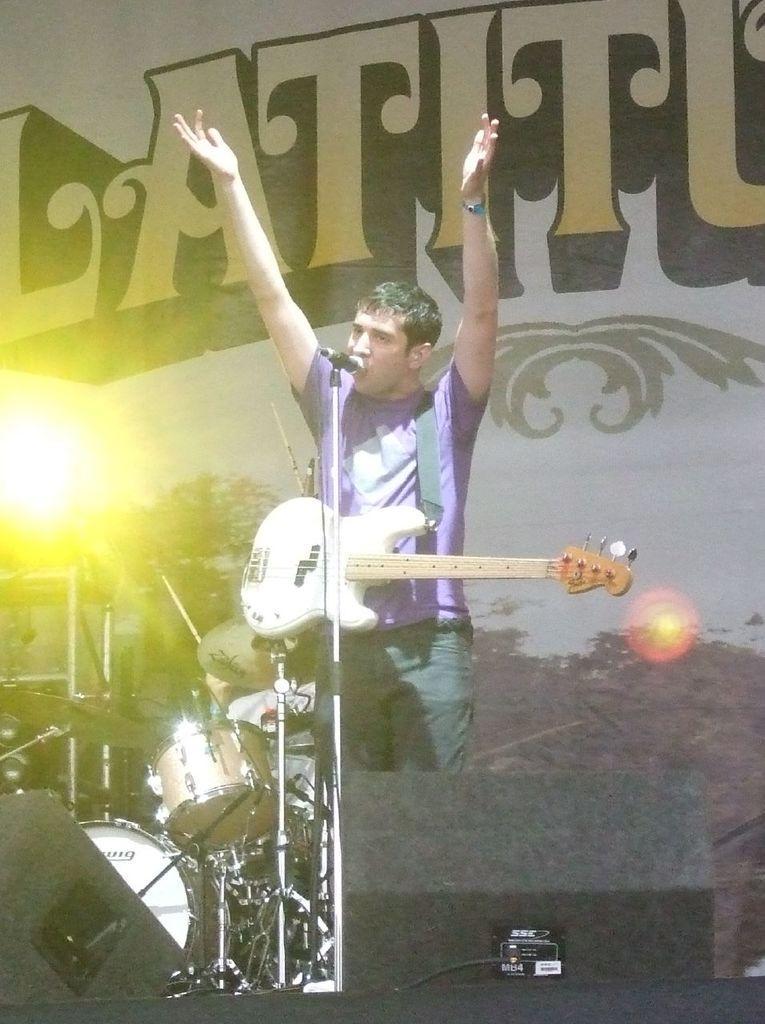In one or two sentences, can you explain what this image depicts? In this image I can see a person is standing in front of a mike and is wearing a guitar and musical instruments on the stage. In the background I can see trees, light, text and the sky. This image is taken may be in the evening. 